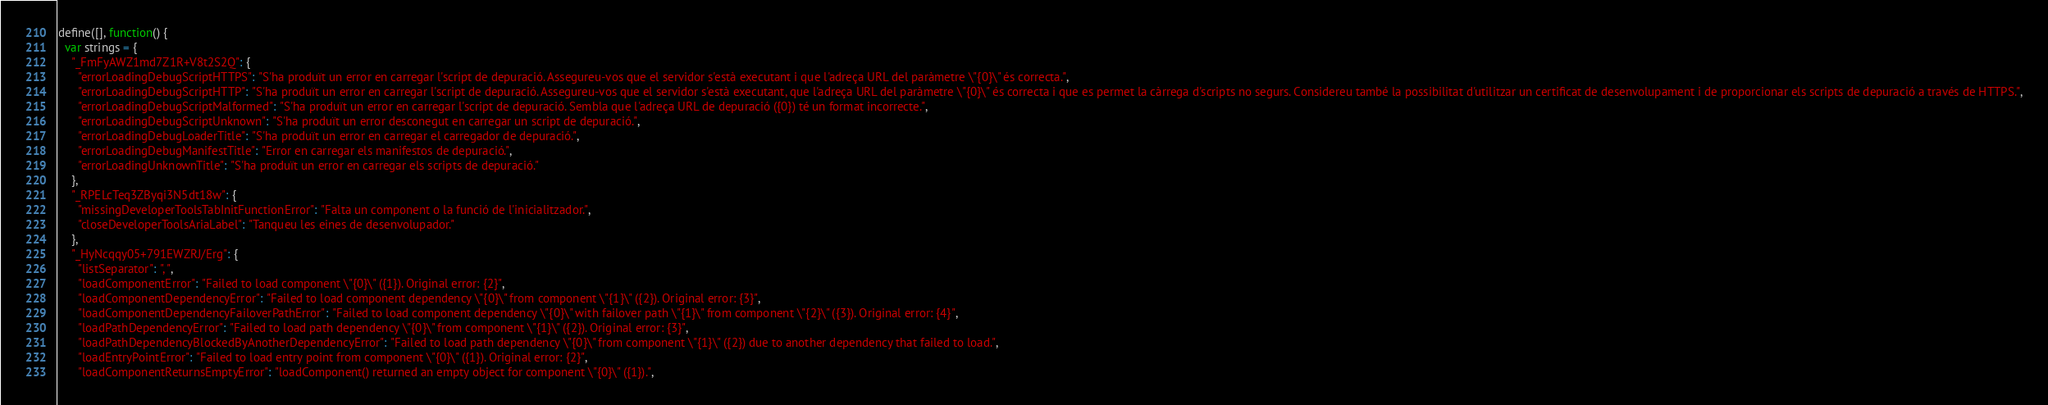<code> <loc_0><loc_0><loc_500><loc_500><_JavaScript_>define([], function() {
  var strings = {
    "_FmFyAWZ1md7Z1R+V8t2S2Q": {
      "errorLoadingDebugScriptHTTPS": "S'ha produït un error en carregar l'script de depuració. Assegureu-vos que el servidor s'està executant i que l'adreça URL del paràmetre \"{0}\" és correcta.",
      "errorLoadingDebugScriptHTTP": "S'ha produït un error en carregar l'script de depuració. Assegureu-vos que el servidor s'està executant, que l'adreça URL del paràmetre \"{0}\" és correcta i que es permet la càrrega d'scripts no segurs. Considereu també la possibilitat d'utilitzar un certificat de desenvolupament i de proporcionar els scripts de depuració a través de HTTPS.",
      "errorLoadingDebugScriptMalformed": "S'ha produït un error en carregar l'script de depuració. Sembla que l'adreça URL de depuració ({0}) té un format incorrecte.",
      "errorLoadingDebugScriptUnknown": "S'ha produït un error desconegut en carregar un script de depuració.",
      "errorLoadingDebugLoaderTitle": "S'ha produït un error en carregar el carregador de depuració.",
      "errorLoadingDebugManifestTitle": "Error en carregar els manifestos de depuració.",
      "errorLoadingUnknownTitle": "S'ha produït un error en carregar els scripts de depuració."
    },
    "_RPELcTeq3ZByqi3N5dt18w": {
      "missingDeveloperToolsTabInitFunctionError": "Falta un component o la funció de l'inicialitzador.",
      "closeDeveloperToolsAriaLabel": "Tanqueu les eines de desenvolupador."
    },
    "_HyNcqqy05+791EWZRJ/Erg": {
      "listSeparator": ", ",
      "loadComponentError": "Failed to load component \"{0}\" ({1}). Original error: {2}",
      "loadComponentDependencyError": "Failed to load component dependency \"{0}\" from component \"{1}\" ({2}). Original error: {3}",
      "loadComponentDependencyFailoverPathError": "Failed to load component dependency \"{0}\" with failover path \"{1}\" from component \"{2}\" ({3}). Original error: {4}",
      "loadPathDependencyError": "Failed to load path dependency \"{0}\" from component \"{1}\" ({2}). Original error: {3}",
      "loadPathDependencyBlockedByAnotherDependencyError": "Failed to load path dependency \"{0}\" from component \"{1}\" ({2}) due to another dependency that failed to load.",
      "loadEntryPointError": "Failed to load entry point from component \"{0}\" ({1}). Original error: {2}",
      "loadComponentReturnsEmptyError": "loadComponent() returned an empty object for component \"{0}\" ({1}).",</code> 